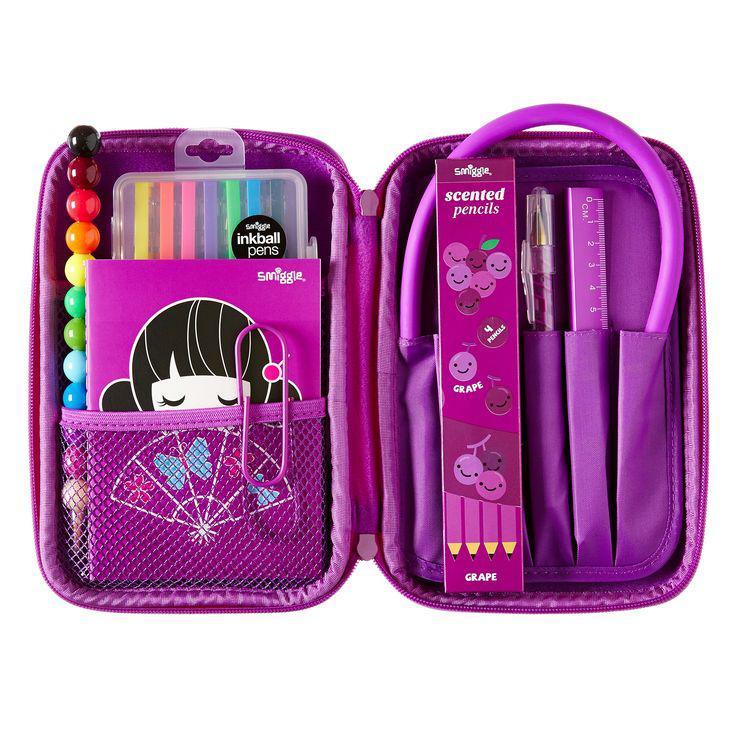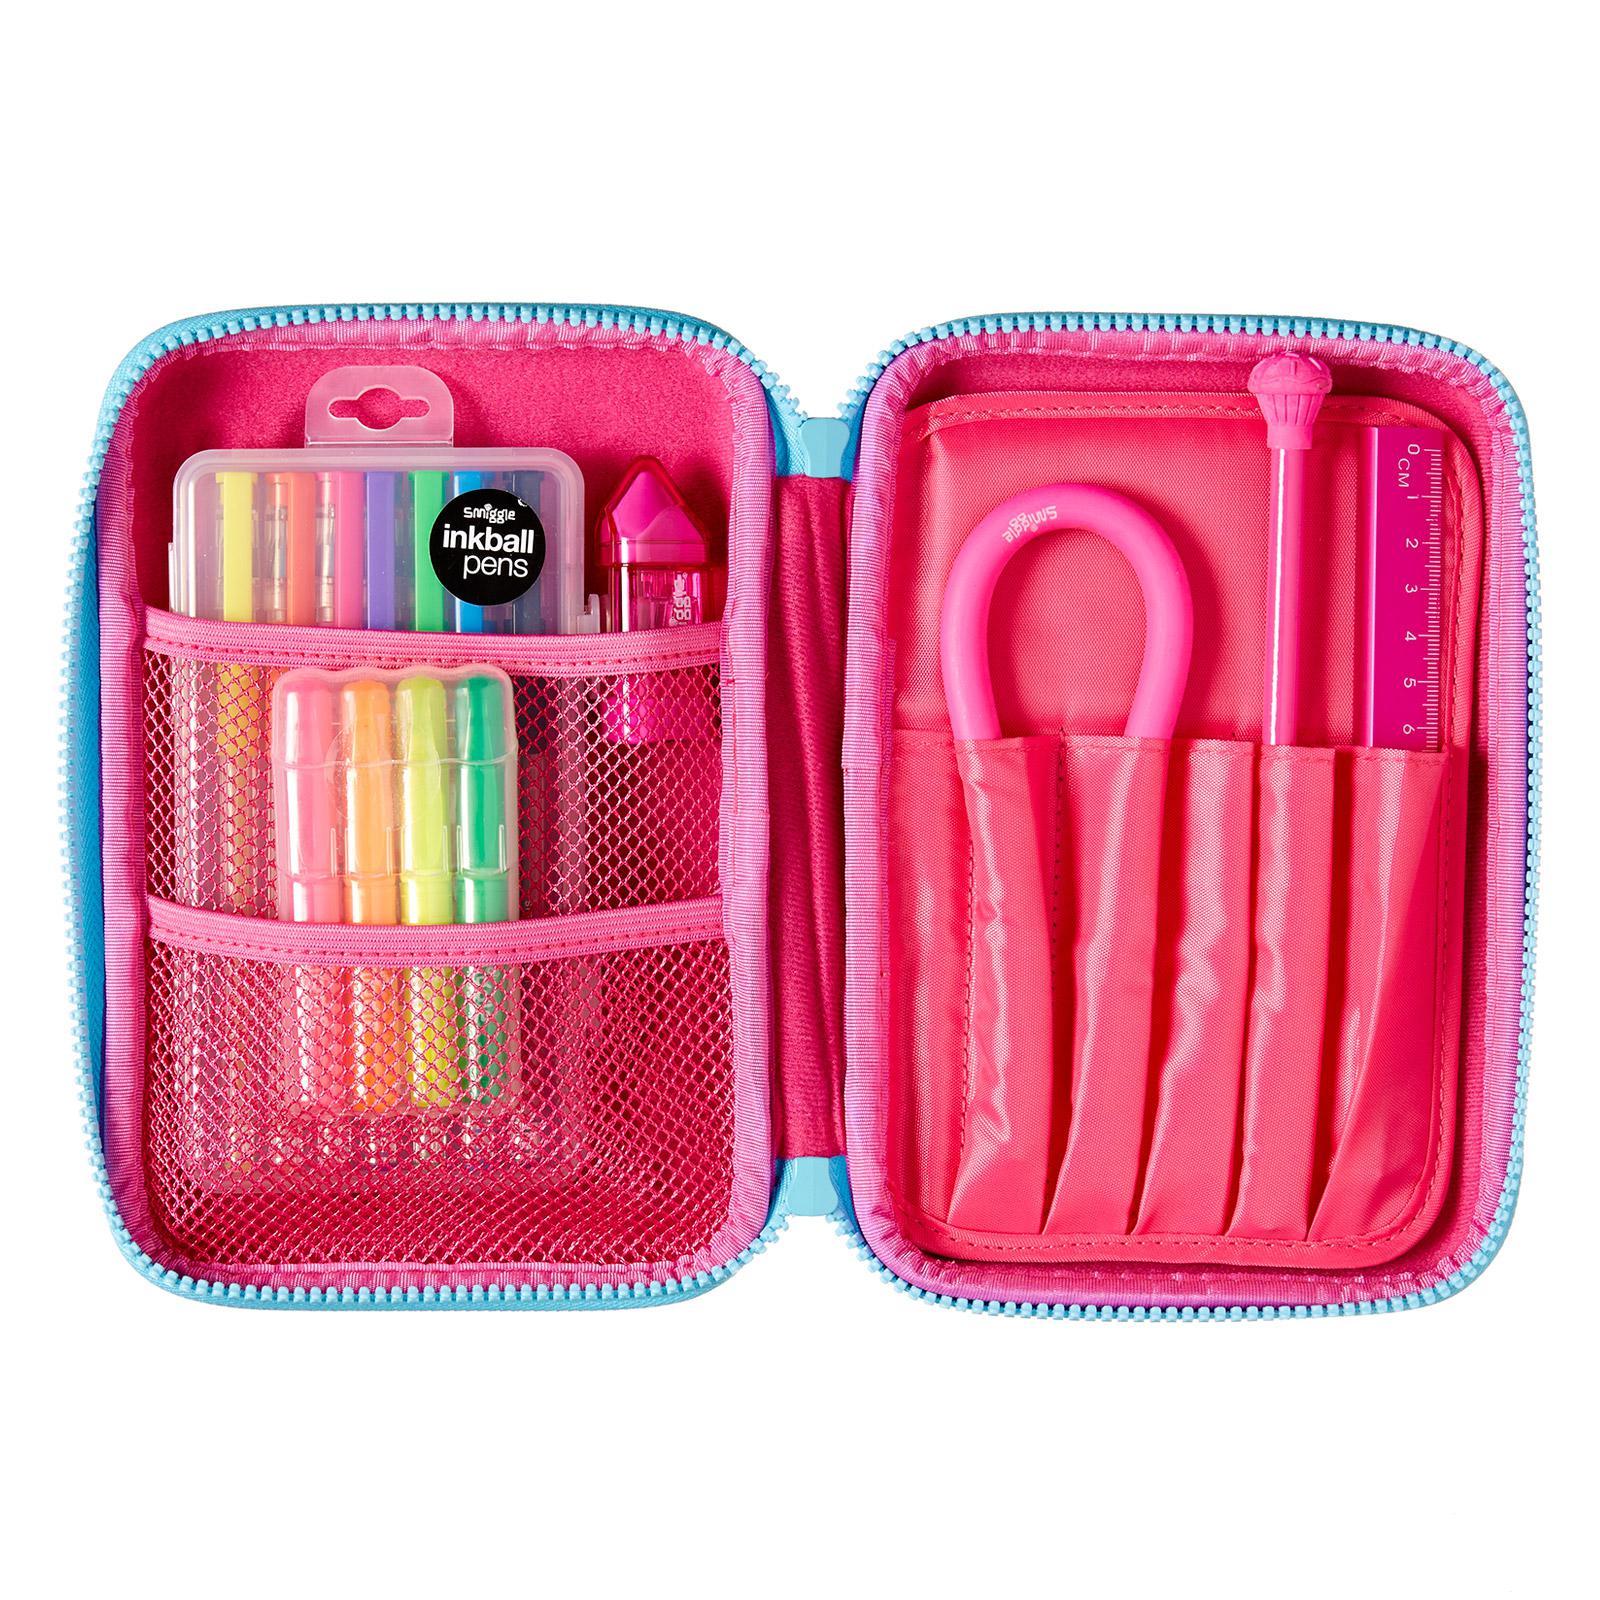The first image is the image on the left, the second image is the image on the right. Given the left and right images, does the statement "One of the containers contains a pair of scissors." hold true? Answer yes or no. No. The first image is the image on the left, the second image is the image on the right. For the images displayed, is the sentence "A pair of scissors is in the pencil pouch next to a pencil." factually correct? Answer yes or no. No. 